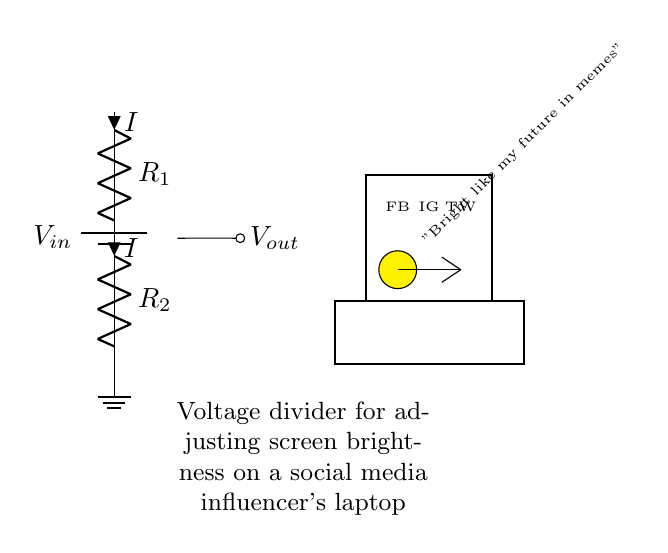What is the input voltage in this circuit? The input voltage, denoted as V_in, is the voltage supplied by the battery at the top of the diagram. The specific value is not indicated in the diagram, but it's essential as the starting point for the voltage divider.
Answer: V_in How many resistors are used in this circuit? The circuit diagram shows two resistors labeled R_1 and R_2. They are connected in series between the input voltage and the ground.
Answer: Two What does the output voltage depend on? The output voltage, known as V_out, depends on the values of R_1 and R_2, as well as the input voltage. According to the voltage divider rule, V_out = (R_2 / (R_1 + R_2)) * V_in. This means the division of voltage is based on the relative resistance values.
Answer: R_1, R_2, V_in What is the purpose of the voltage divider in the context of this circuit? The purpose of the voltage divider is to adjust the screen brightness on the laptop for the social media influencer. By changing the ratio of the resistors, you can control how much voltage is applied to the screen, which in turn affects the brightness.
Answer: Adjusting brightness If R_1 is twice the value of R_2, what happens to the brightness? If R_1 is twice the value of R_2, using the voltage divider formula will result in a lower output voltage (V_out), leading to dimmer screen brightness. As R_1 increases relative to R_2, a smaller fraction of V_in appears across R_2, thus reducing the output voltage.
Answer: Dimmer What would happen if R_1 was removed from the circuit? If R_1 is removed, only R_2 will remain, acting as a direct path for V_in to ground. This would make V_out equal to V_in, resulting in maximum brightness since the full voltage is applied to the screen without any division.
Answer: Maximum brightness 